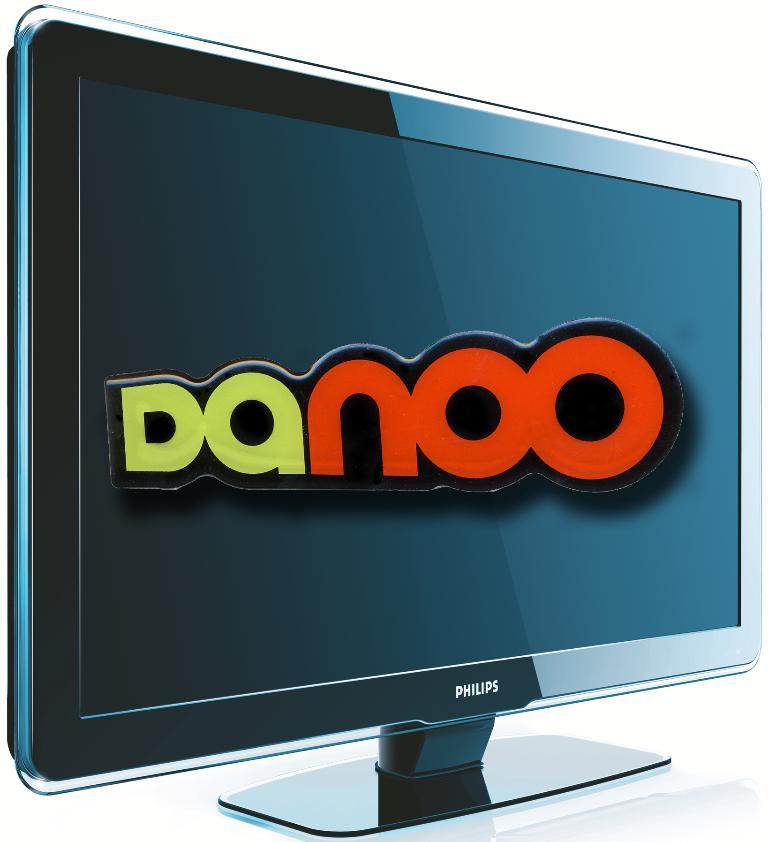What is the monitor brand name?
Make the answer very short. Philips. What word is displayed in big letters on the screen?
Ensure brevity in your answer.  Danoo. 